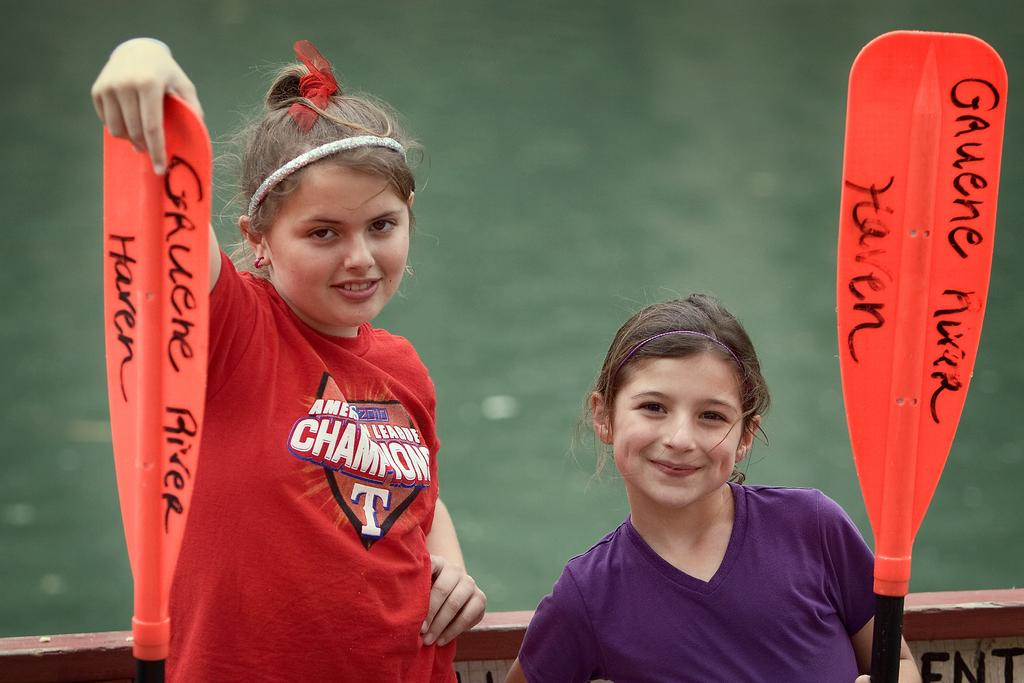<image>
Give a short and clear explanation of the subsequent image. two girls next to each other with one wearing a championship shirt 